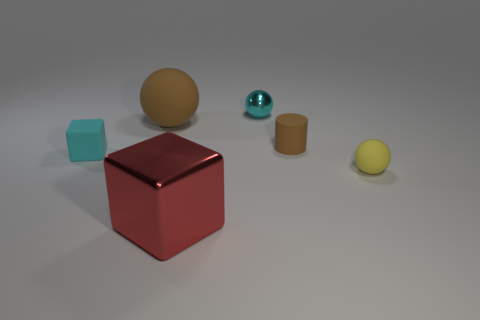Add 1 big purple metallic spheres. How many objects exist? 7 Subtract all cylinders. How many objects are left? 5 Subtract 0 purple cubes. How many objects are left? 6 Subtract all cyan balls. Subtract all things. How many objects are left? 4 Add 6 tiny yellow rubber things. How many tiny yellow rubber things are left? 7 Add 4 tiny red shiny balls. How many tiny red shiny balls exist? 4 